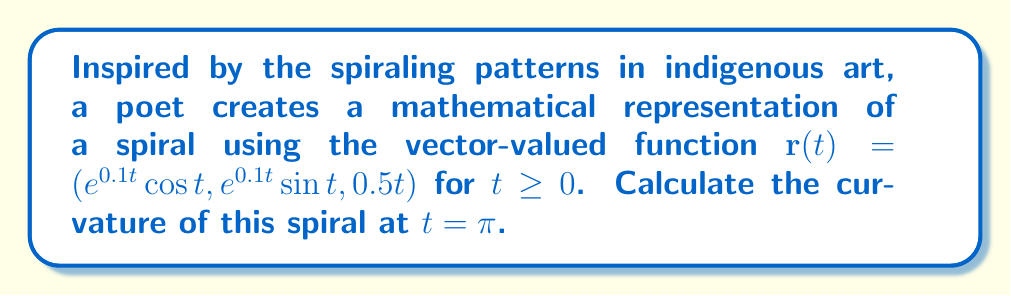Could you help me with this problem? To calculate the curvature of the spiral, we'll use the formula:

$$\kappa = \frac{|\mathbf{r}'(t) \times \mathbf{r}''(t)|}{|\mathbf{r}'(t)|^3}$$

Step 1: Calculate $\mathbf{r}'(t)$
$$\mathbf{r}'(t) = (0.1e^{0.1t} \cos t - e^{0.1t} \sin t, 0.1e^{0.1t} \sin t + e^{0.1t} \cos t, 0.5)$$

Step 2: Calculate $\mathbf{r}''(t)$
$$\mathbf{r}''(t) = ((0.01-1)e^{0.1t} \cos t - 0.2e^{0.1t} \sin t, (0.01-1)e^{0.1t} \sin t + 0.2e^{0.1t} \cos t, 0)$$

Step 3: Evaluate $\mathbf{r}'(\pi)$ and $\mathbf{r}''(\pi)$
$$\mathbf{r}'(\pi) = (-e^{0.1\pi}, 0.1e^{0.1\pi}, 0.5)$$
$$\mathbf{r}''(\pi) = (-(0.99)e^{0.1\pi}, 0.2e^{0.1\pi}, 0)$$

Step 4: Calculate $\mathbf{r}'(\pi) \times \mathbf{r}''(\pi)$
$$\mathbf{r}'(\pi) \times \mathbf{r}''(\pi) = (0.1e^{0.2\pi}, 0.5(0.99)e^{0.1\pi}, -0.2e^{0.2\pi} - 0.5(0.1)e^{0.1\pi})$$

Step 5: Calculate $|\mathbf{r}'(\pi) \times \mathbf{r}''(\pi)|$
$$|\mathbf{r}'(\pi) \times \mathbf{r}''(\pi)| = \sqrt{(0.1e^{0.2\pi})^2 + (0.5(0.99)e^{0.1\pi})^2 + (-0.2e^{0.2\pi} - 0.5(0.1)e^{0.1\pi})^2}$$

Step 6: Calculate $|\mathbf{r}'(\pi)|$
$$|\mathbf{r}'(\pi)| = \sqrt{e^{0.2\pi} + 0.01e^{0.2\pi} + 0.25}$$

Step 7: Apply the curvature formula
$$\kappa = \frac{\sqrt{(0.1e^{0.2\pi})^2 + (0.5(0.99)e^{0.1\pi})^2 + (-0.2e^{0.2\pi} - 0.5(0.1)e^{0.1\pi})^2}}{(e^{0.2\pi} + 0.01e^{0.2\pi} + 0.25)^{3/2}}$$
Answer: The curvature of the spiral at $t = \pi$ is:

$$\kappa = \frac{\sqrt{(0.1e^{0.2\pi})^2 + (0.5(0.99)e^{0.1\pi})^2 + (-0.2e^{0.2\pi} - 0.5(0.1)e^{0.1\pi})^2}}{(e^{0.2\pi} + 0.01e^{0.2\pi} + 0.25)^{3/2}}$$ 